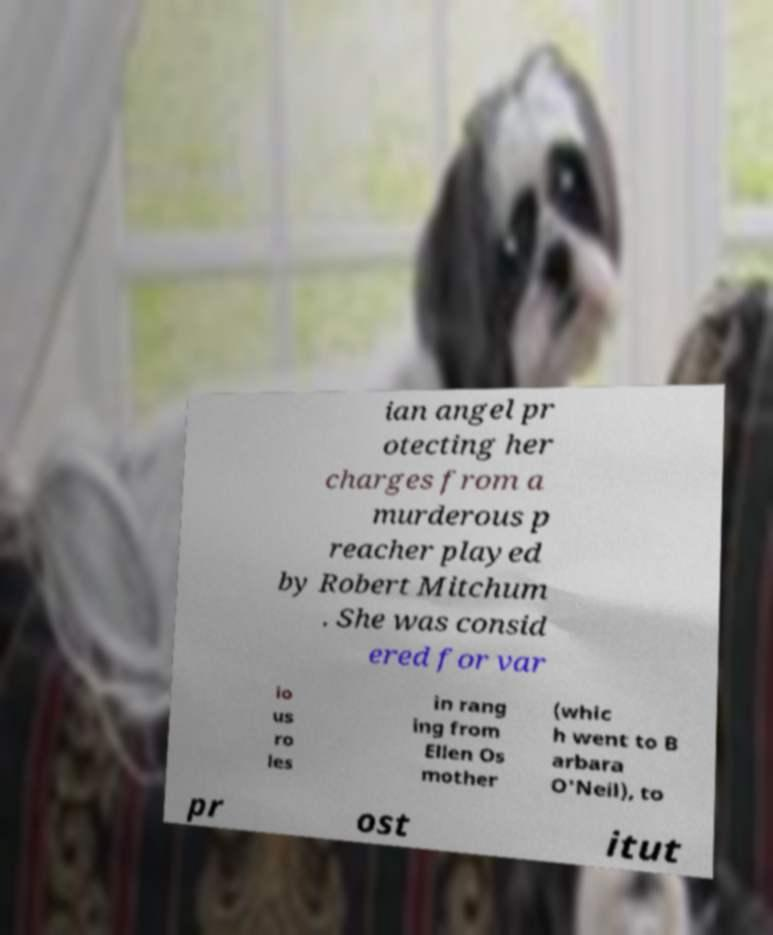What messages or text are displayed in this image? I need them in a readable, typed format. ian angel pr otecting her charges from a murderous p reacher played by Robert Mitchum . She was consid ered for var io us ro les in rang ing from Ellen Os mother (whic h went to B arbara O'Neil), to pr ost itut 